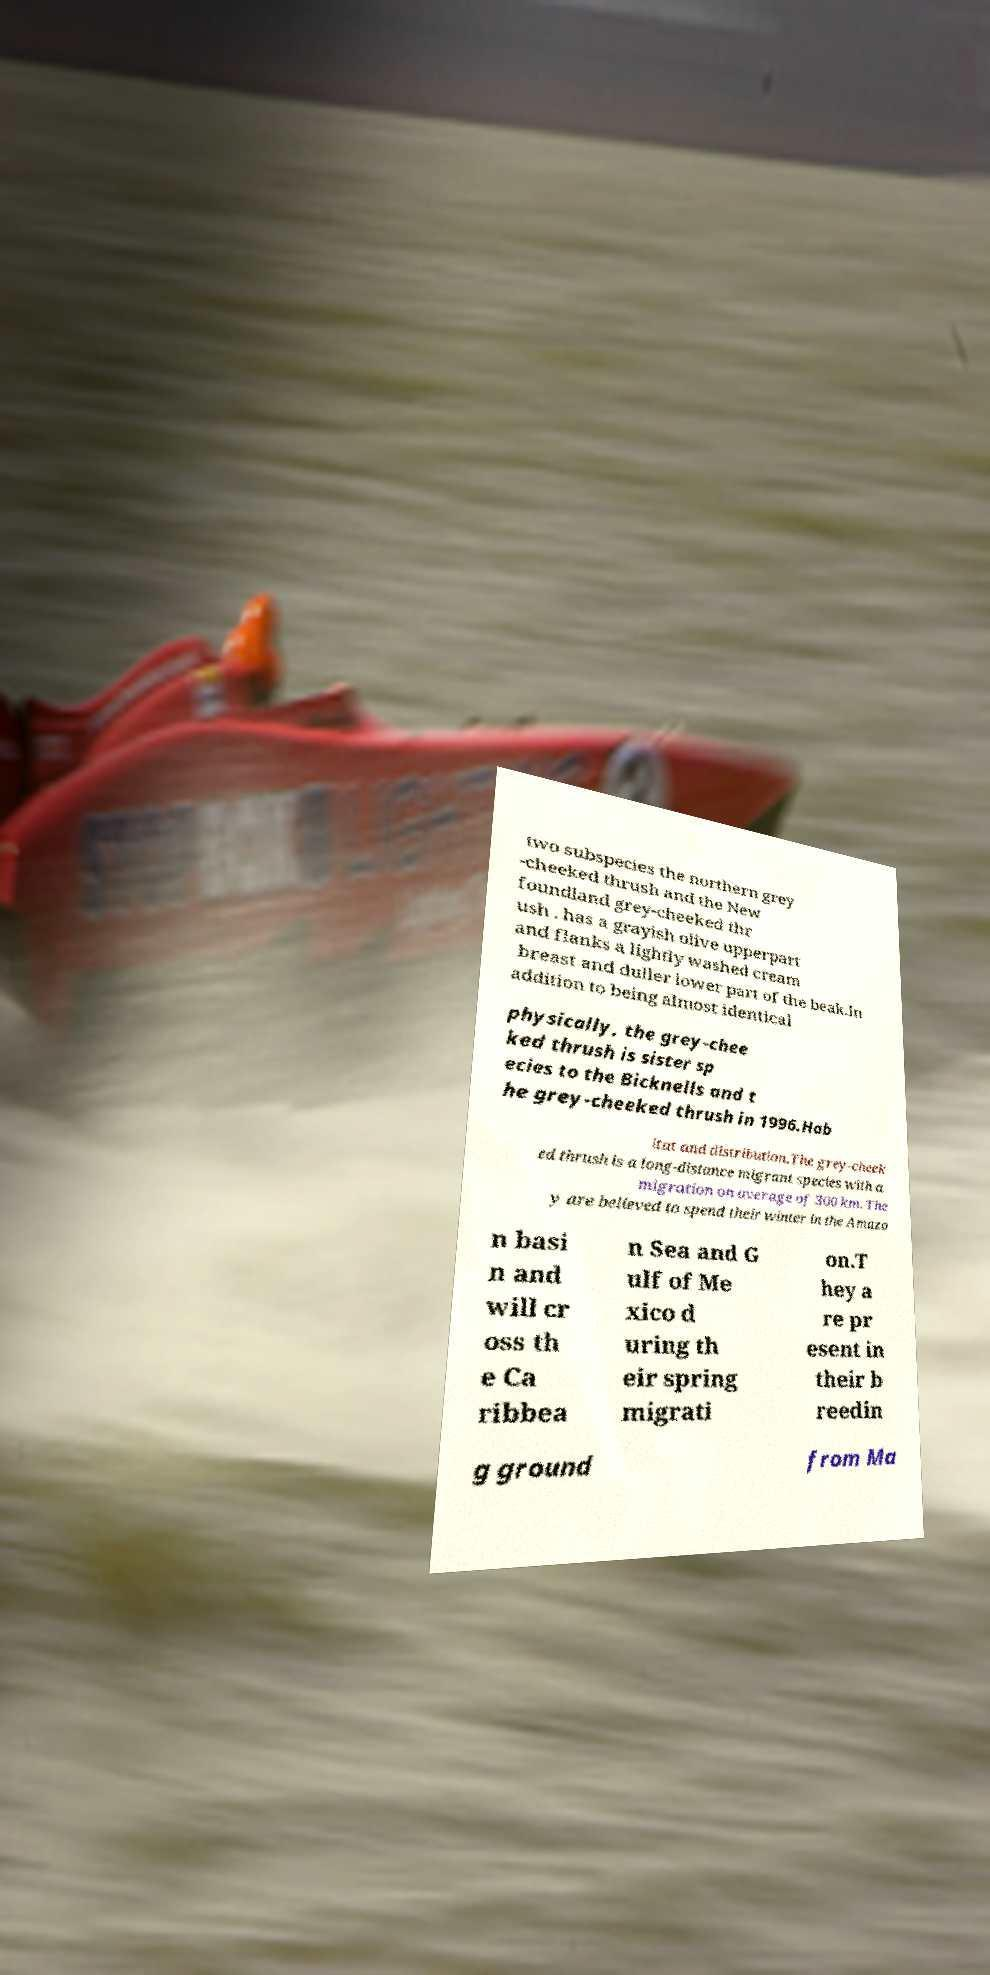For documentation purposes, I need the text within this image transcribed. Could you provide that? two subspecies the northern grey -cheeked thrush and the New foundland grey-cheeked thr ush . has a grayish olive upperpart and flanks a lightly washed cream breast and duller lower part of the beak.In addition to being almost identical physically, the grey-chee ked thrush is sister sp ecies to the Bicknells and t he grey-cheeked thrush in 1996.Hab itat and distribution.The grey-cheek ed thrush is a long-distance migrant species with a migration on average of 300 km. The y are believed to spend their winter in the Amazo n basi n and will cr oss th e Ca ribbea n Sea and G ulf of Me xico d uring th eir spring migrati on.T hey a re pr esent in their b reedin g ground from Ma 